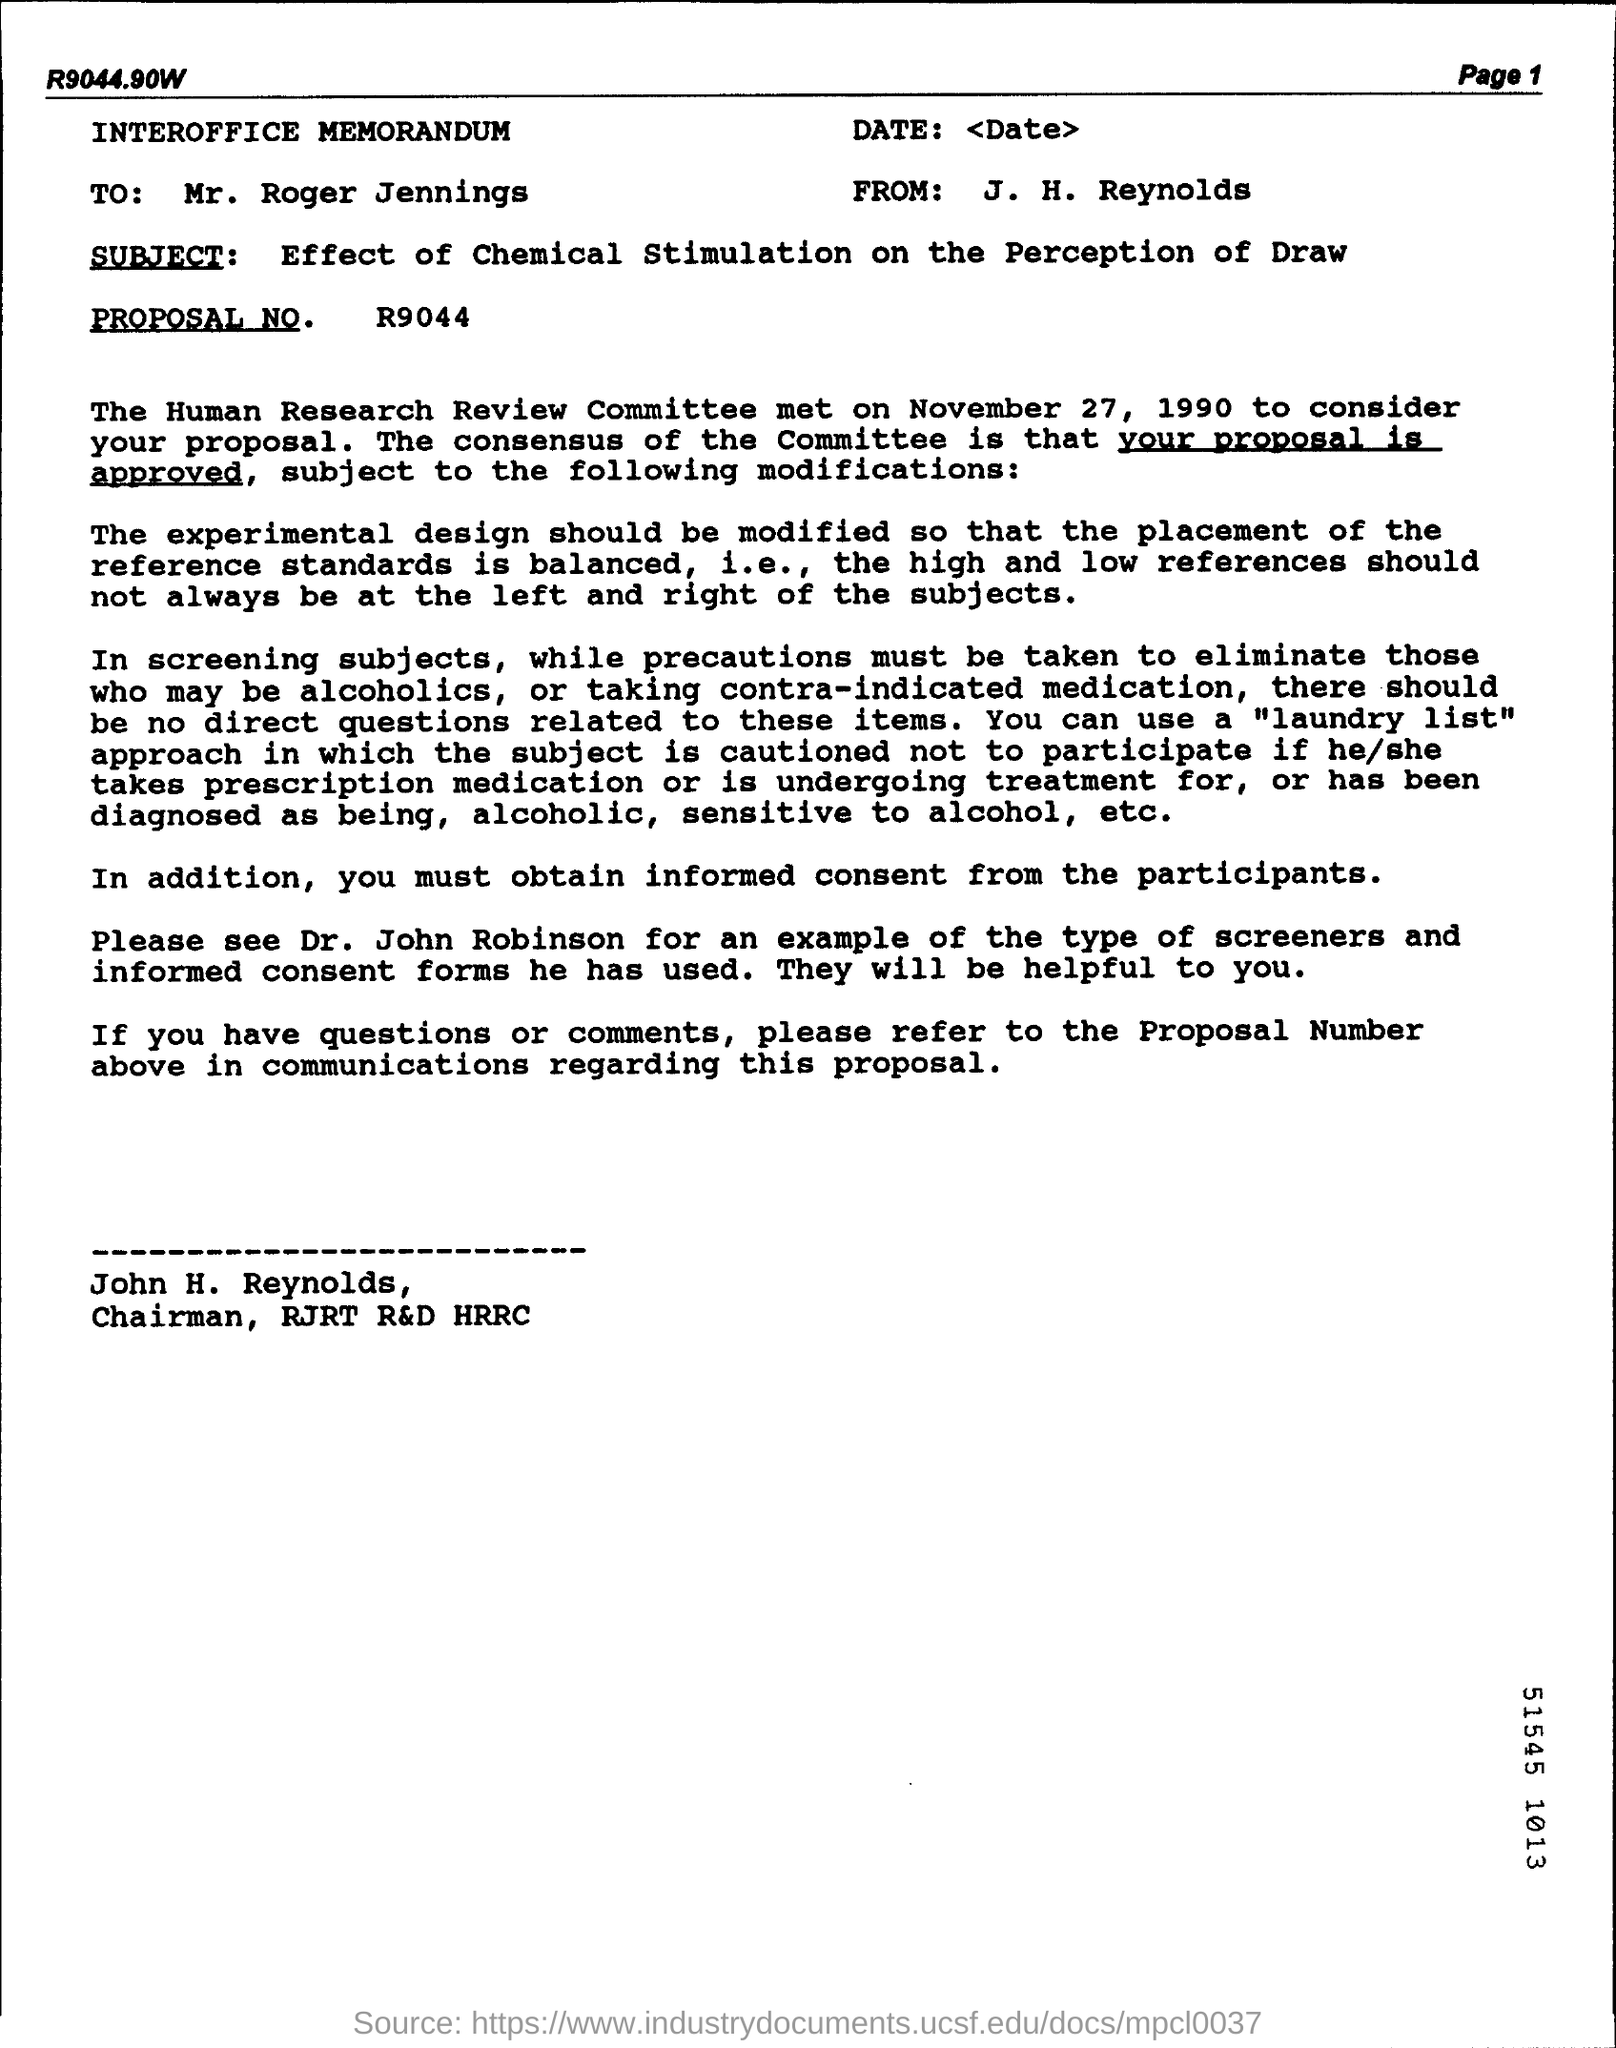Point out several critical features in this image. The letter is addressed to Mr. Roger Jennings. The proposal number is R9044. The Human Research Committee met on November 27, 1990, to consider the proposal. The title of the letter is 'INTEROFFICE MEMORANDUM.' The subject of the letter is the effect of chemical stimulation on the perception of drawings. 